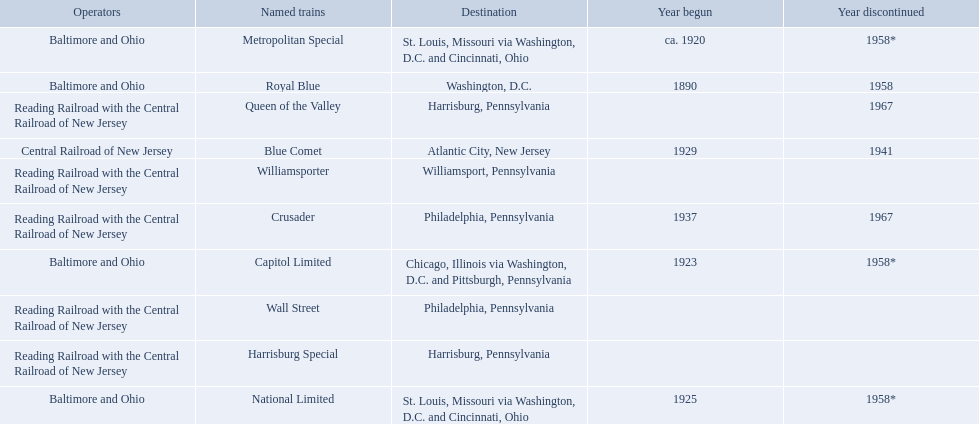Which operators are the reading railroad with the central railroad of new jersey? Reading Railroad with the Central Railroad of New Jersey, Reading Railroad with the Central Railroad of New Jersey, Reading Railroad with the Central Railroad of New Jersey, Reading Railroad with the Central Railroad of New Jersey, Reading Railroad with the Central Railroad of New Jersey. Which destinations are philadelphia, pennsylvania? Philadelphia, Pennsylvania, Philadelphia, Pennsylvania. What on began in 1937? 1937. What is the named train? Crusader. 